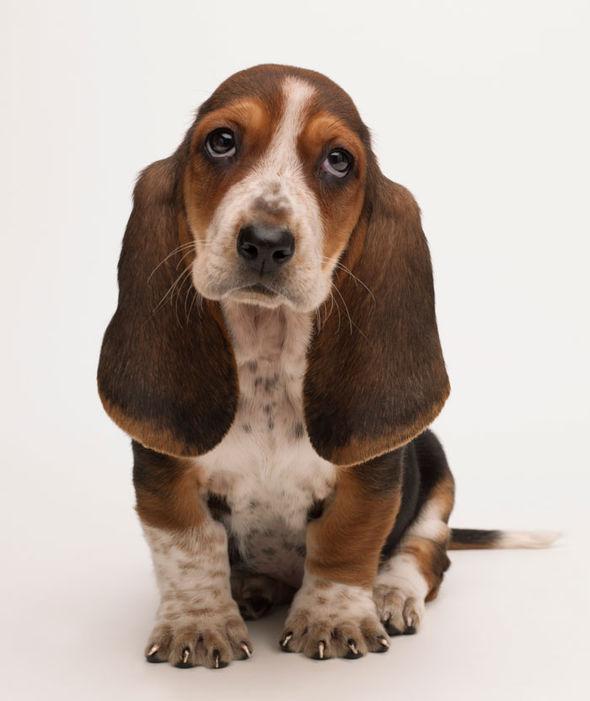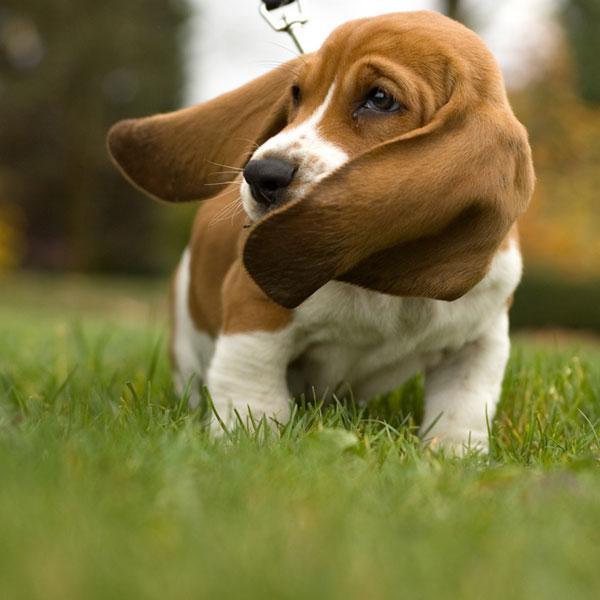The first image is the image on the left, the second image is the image on the right. Analyze the images presented: Is the assertion "Each image shows a basset hound, and the hound on the right looks sleepy-eyed." valid? Answer yes or no. No. The first image is the image on the left, the second image is the image on the right. Considering the images on both sides, is "There is a small puppy with brown floppy ears sitting on white snow." valid? Answer yes or no. No. 